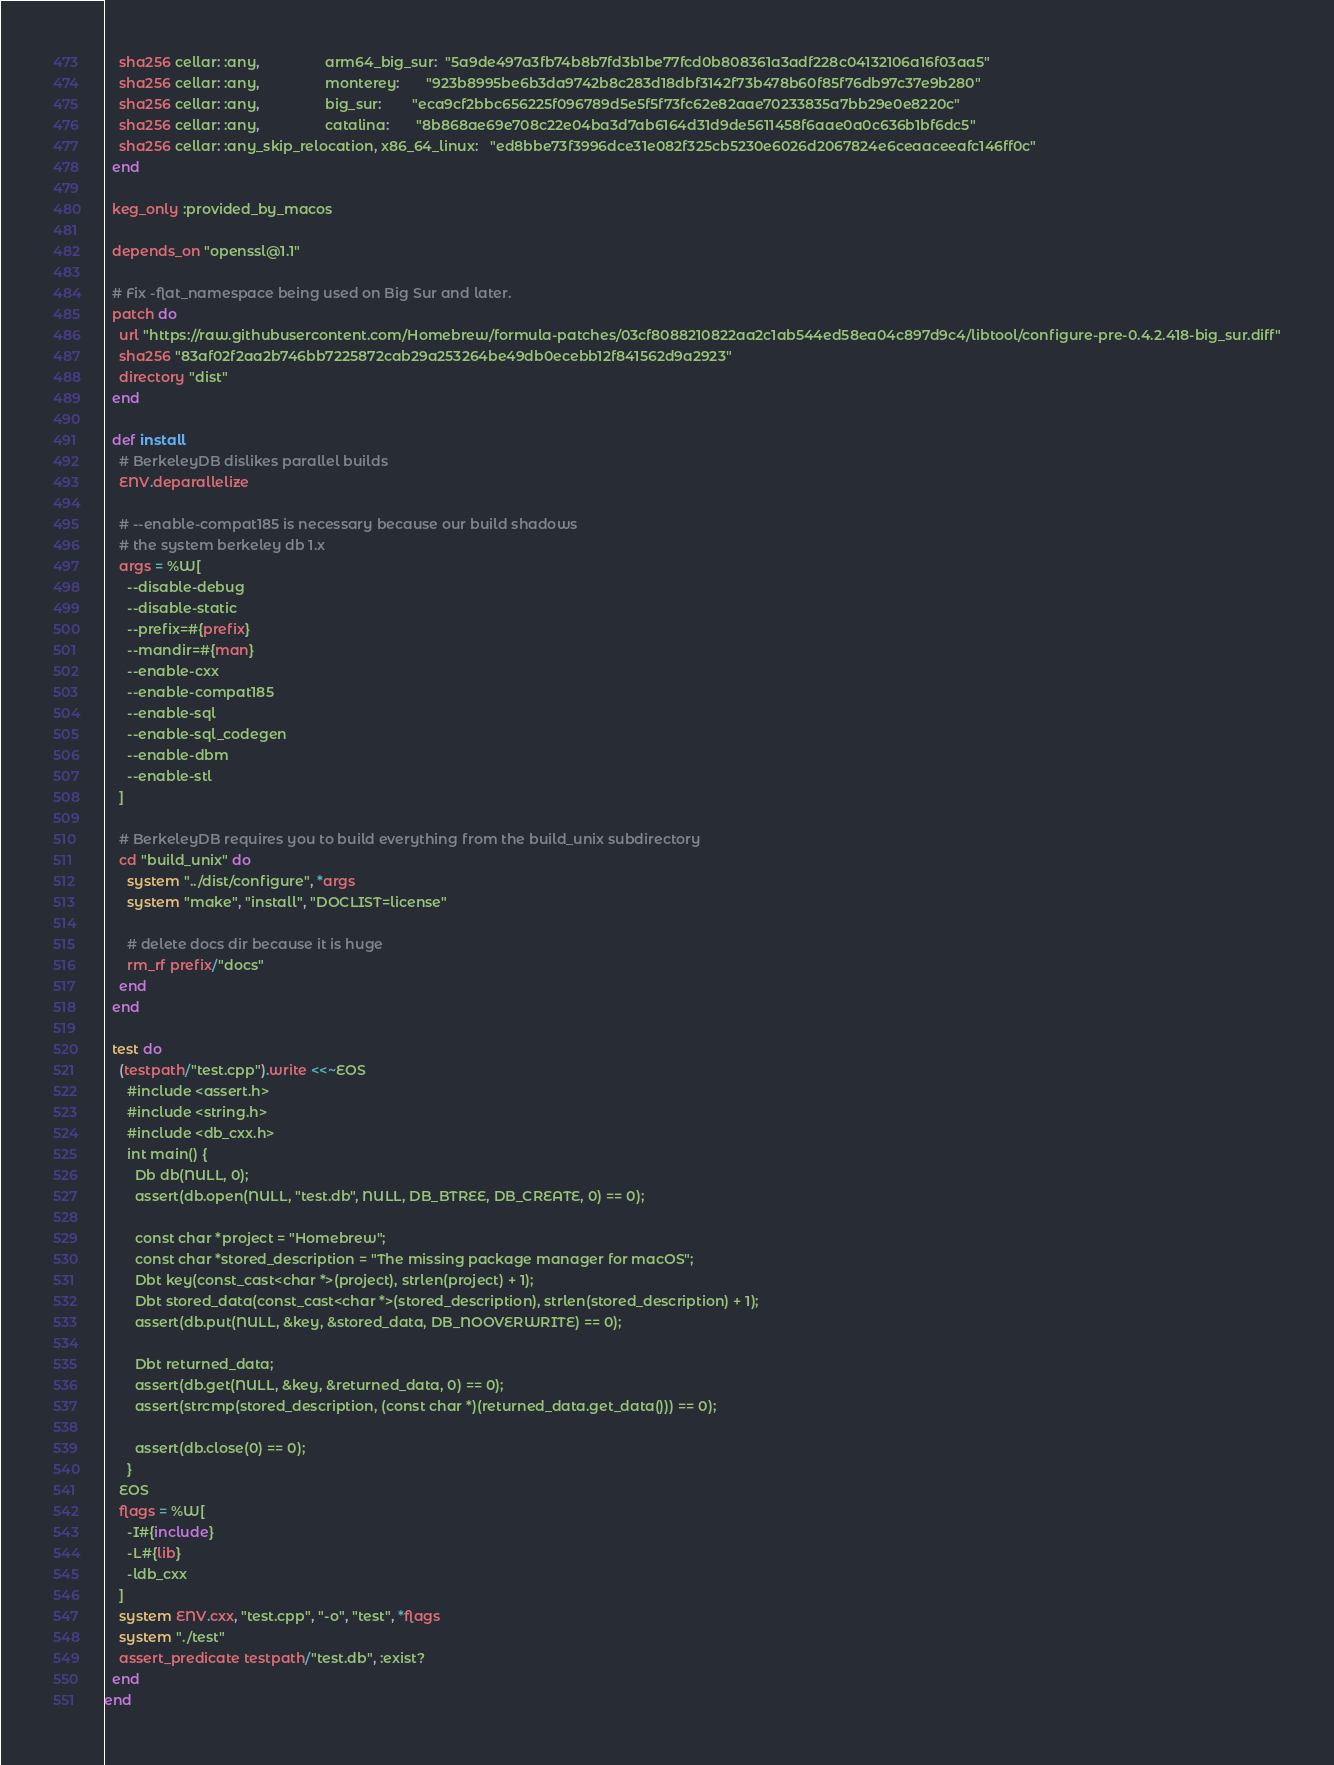Convert code to text. <code><loc_0><loc_0><loc_500><loc_500><_Ruby_>    sha256 cellar: :any,                 arm64_big_sur:  "5a9de497a3fb74b8b7fd3b1be77fcd0b808361a3adf228c04132106a16f03aa5"
    sha256 cellar: :any,                 monterey:       "923b8995be6b3da9742b8c283d18dbf3142f73b478b60f85f76db97c37e9b280"
    sha256 cellar: :any,                 big_sur:        "eca9cf2bbc656225f096789d5e5f5f73fc62e82aae70233835a7bb29e0e8220c"
    sha256 cellar: :any,                 catalina:       "8b868ae69e708c22e04ba3d7ab6164d31d9de5611458f6aae0a0c636b1bf6dc5"
    sha256 cellar: :any_skip_relocation, x86_64_linux:   "ed8bbe73f3996dce31e082f325cb5230e6026d2067824e6ceaaceeafc146ff0c"
  end

  keg_only :provided_by_macos

  depends_on "openssl@1.1"

  # Fix -flat_namespace being used on Big Sur and later.
  patch do
    url "https://raw.githubusercontent.com/Homebrew/formula-patches/03cf8088210822aa2c1ab544ed58ea04c897d9c4/libtool/configure-pre-0.4.2.418-big_sur.diff"
    sha256 "83af02f2aa2b746bb7225872cab29a253264be49db0ecebb12f841562d9a2923"
    directory "dist"
  end

  def install
    # BerkeleyDB dislikes parallel builds
    ENV.deparallelize

    # --enable-compat185 is necessary because our build shadows
    # the system berkeley db 1.x
    args = %W[
      --disable-debug
      --disable-static
      --prefix=#{prefix}
      --mandir=#{man}
      --enable-cxx
      --enable-compat185
      --enable-sql
      --enable-sql_codegen
      --enable-dbm
      --enable-stl
    ]

    # BerkeleyDB requires you to build everything from the build_unix subdirectory
    cd "build_unix" do
      system "../dist/configure", *args
      system "make", "install", "DOCLIST=license"

      # delete docs dir because it is huge
      rm_rf prefix/"docs"
    end
  end

  test do
    (testpath/"test.cpp").write <<~EOS
      #include <assert.h>
      #include <string.h>
      #include <db_cxx.h>
      int main() {
        Db db(NULL, 0);
        assert(db.open(NULL, "test.db", NULL, DB_BTREE, DB_CREATE, 0) == 0);

        const char *project = "Homebrew";
        const char *stored_description = "The missing package manager for macOS";
        Dbt key(const_cast<char *>(project), strlen(project) + 1);
        Dbt stored_data(const_cast<char *>(stored_description), strlen(stored_description) + 1);
        assert(db.put(NULL, &key, &stored_data, DB_NOOVERWRITE) == 0);

        Dbt returned_data;
        assert(db.get(NULL, &key, &returned_data, 0) == 0);
        assert(strcmp(stored_description, (const char *)(returned_data.get_data())) == 0);

        assert(db.close(0) == 0);
      }
    EOS
    flags = %W[
      -I#{include}
      -L#{lib}
      -ldb_cxx
    ]
    system ENV.cxx, "test.cpp", "-o", "test", *flags
    system "./test"
    assert_predicate testpath/"test.db", :exist?
  end
end
</code> 